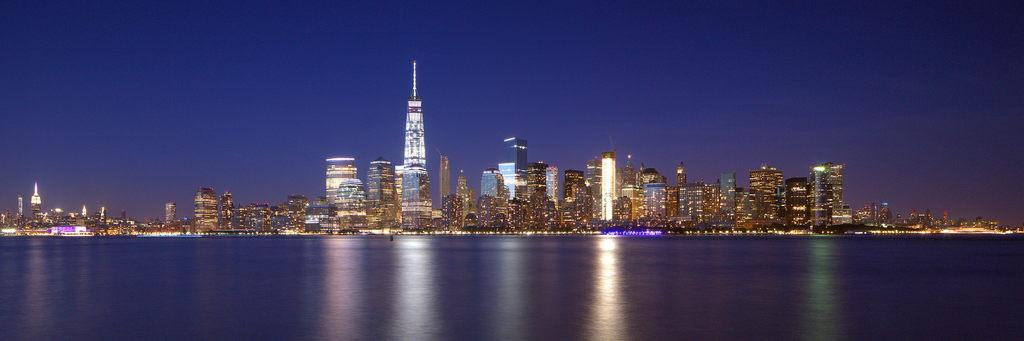What is visible in the image? Water, buildings, lights on the buildings, and the sky are visible in the image. Can you describe the buildings in the image? The buildings in the image have lights on them. What is the background of the image? The sky is visible in the background of the image. Can you provide an example of an orange in the image? There is no orange present in the image. What type of list can be seen in the image? There is no list present in the image. 